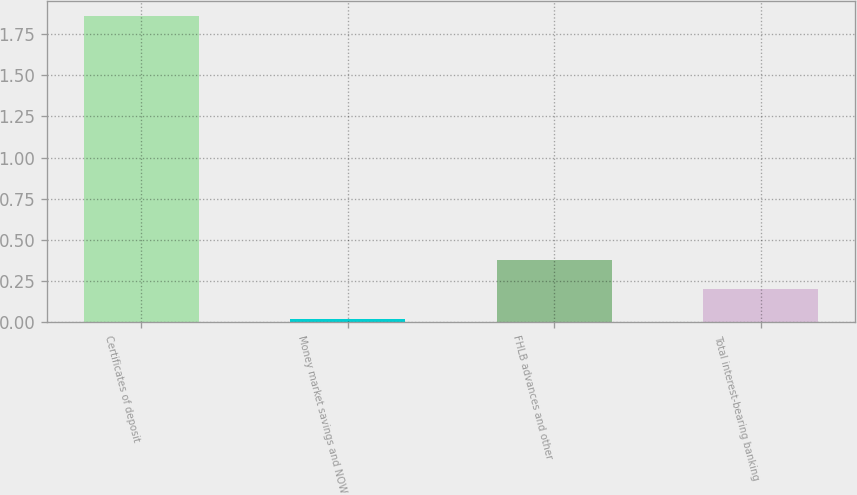Convert chart. <chart><loc_0><loc_0><loc_500><loc_500><bar_chart><fcel>Certificates of deposit<fcel>Money market savings and NOW<fcel>FHLB advances and other<fcel>Total interest-bearing banking<nl><fcel>1.86<fcel>0.02<fcel>0.38<fcel>0.2<nl></chart> 